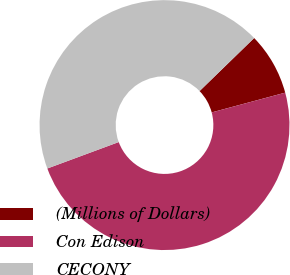Convert chart. <chart><loc_0><loc_0><loc_500><loc_500><pie_chart><fcel>(Millions of Dollars)<fcel>Con Edison<fcel>CECONY<nl><fcel>8.09%<fcel>48.54%<fcel>43.38%<nl></chart> 